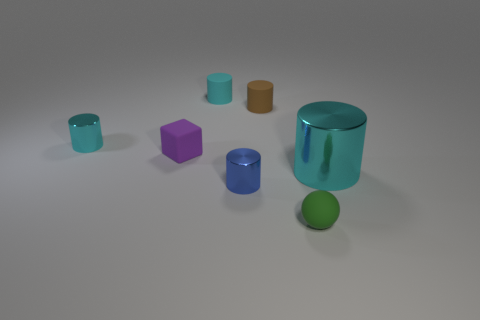How many cyan cylinders must be subtracted to get 1 cyan cylinders? 2 Subtract all purple balls. How many cyan cylinders are left? 3 Subtract all blue cylinders. How many cylinders are left? 4 Subtract all blue cylinders. How many cylinders are left? 4 Add 2 blue things. How many objects exist? 9 Subtract all purple cylinders. Subtract all purple balls. How many cylinders are left? 5 Subtract all cylinders. How many objects are left? 2 Subtract all big cyan cylinders. Subtract all brown cylinders. How many objects are left? 5 Add 6 cyan rubber cylinders. How many cyan rubber cylinders are left? 7 Add 6 big objects. How many big objects exist? 7 